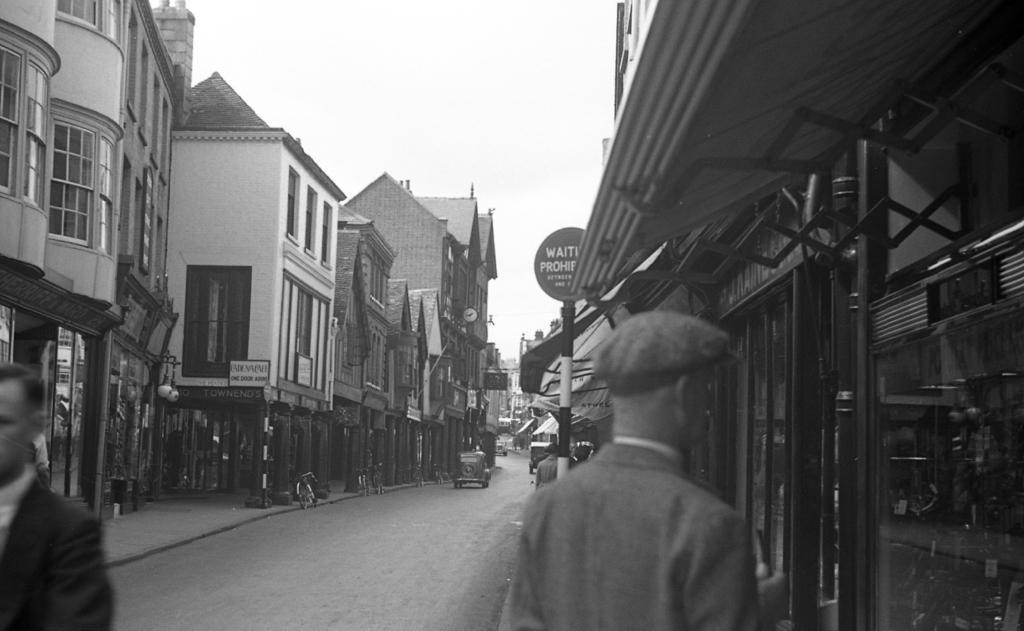In one or two sentences, can you explain what this image depicts? In this image I can see few buildings, windows, stores, poles, signboards, vehicles and few people. The image is in black and white. 